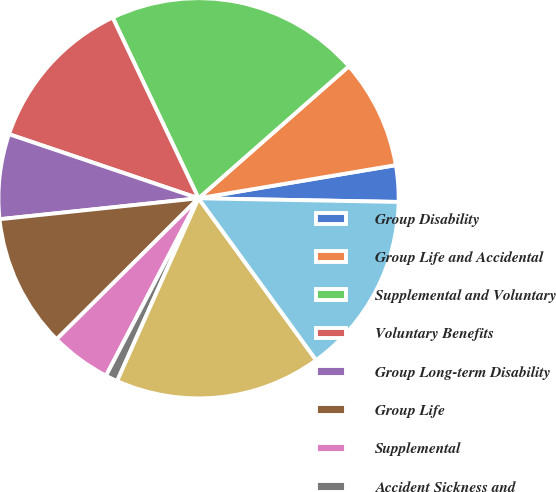Convert chart. <chart><loc_0><loc_0><loc_500><loc_500><pie_chart><fcel>Group Disability<fcel>Group Life and Accidental<fcel>Supplemental and Voluntary<fcel>Voluntary Benefits<fcel>Group Long-term Disability<fcel>Group Life<fcel>Supplemental<fcel>Accident Sickness and<fcel>Life<fcel>Cancer and Critical Illness<nl><fcel>2.94%<fcel>8.82%<fcel>20.59%<fcel>12.75%<fcel>6.86%<fcel>10.78%<fcel>4.9%<fcel>0.98%<fcel>16.67%<fcel>14.71%<nl></chart> 